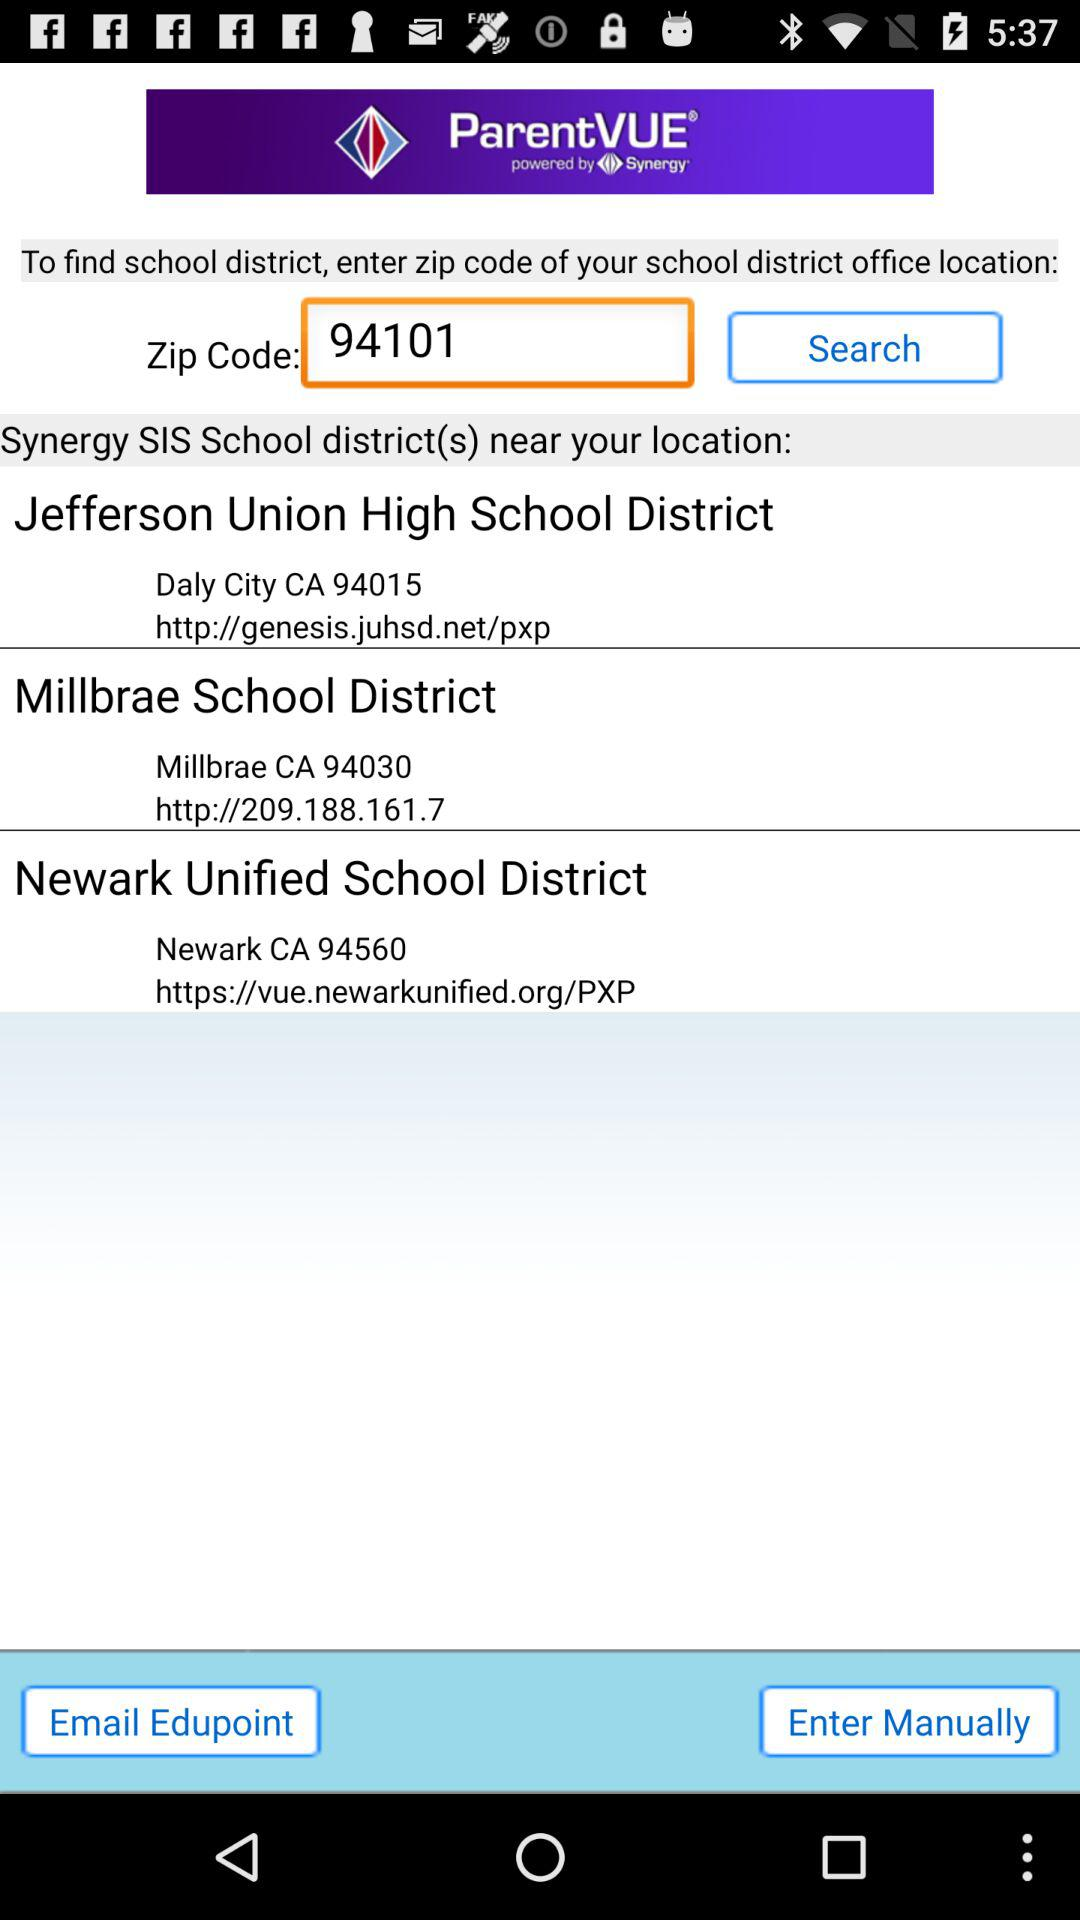What is the entered zip code? The entered zip code is 94101. 